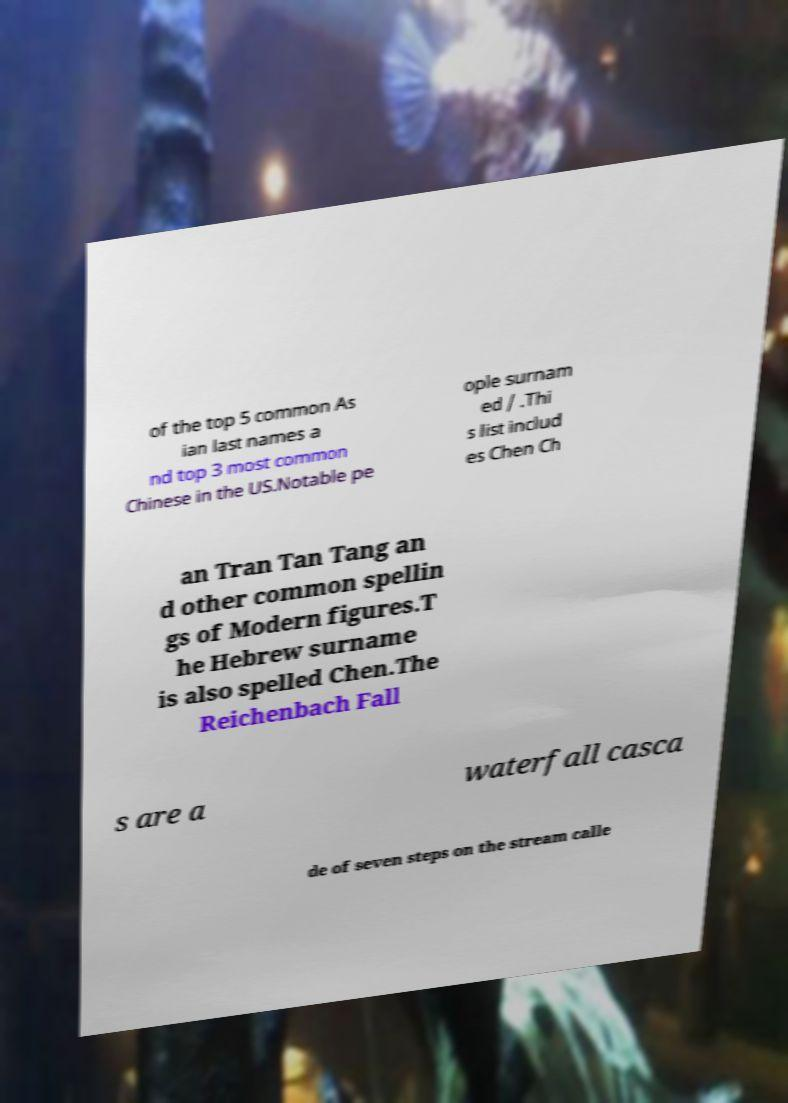Please read and relay the text visible in this image. What does it say? of the top 5 common As ian last names a nd top 3 most common Chinese in the US.Notable pe ople surnam ed / .Thi s list includ es Chen Ch an Tran Tan Tang an d other common spellin gs of Modern figures.T he Hebrew surname is also spelled Chen.The Reichenbach Fall s are a waterfall casca de of seven steps on the stream calle 